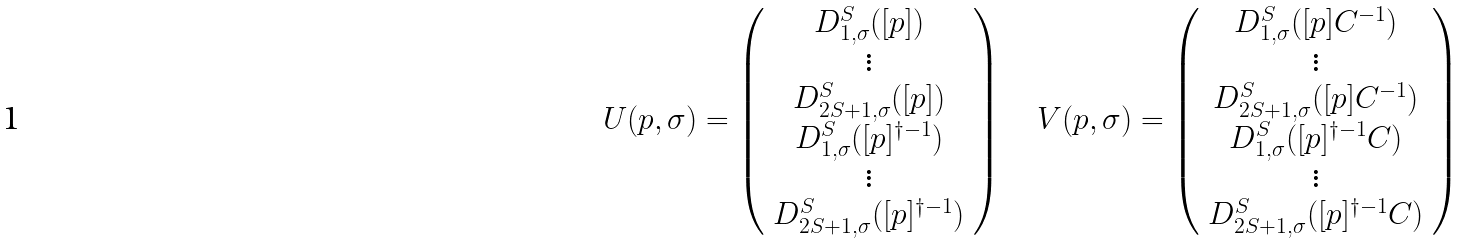<formula> <loc_0><loc_0><loc_500><loc_500>U ( p , \sigma ) = \left ( \begin{array} { c } D ^ { S } _ { 1 , \sigma } ( [ p ] ) \\ \vdots \\ D ^ { S } _ { 2 S + 1 , \sigma } ( [ p ] ) \\ D ^ { S } _ { 1 , \sigma } ( [ p ] ^ { \dagger - 1 } ) \\ \vdots \\ D ^ { S } _ { 2 S + 1 , \sigma } ( [ p ] ^ { \dagger - 1 } ) \end{array} \right ) \quad V ( p , \sigma ) = \left ( \begin{array} { c } D ^ { S } _ { 1 , \sigma } ( [ p ] C ^ { - 1 } ) \\ \vdots \\ D ^ { S } _ { 2 S + 1 , \sigma } ( [ p ] C ^ { - 1 } ) \\ D ^ { S } _ { 1 , \sigma } ( [ p ] ^ { \dagger - 1 } C ) \\ \vdots \\ D ^ { S } _ { 2 S + 1 , \sigma } ( [ p ] ^ { \dagger - 1 } C ) \end{array} \right )</formula> 